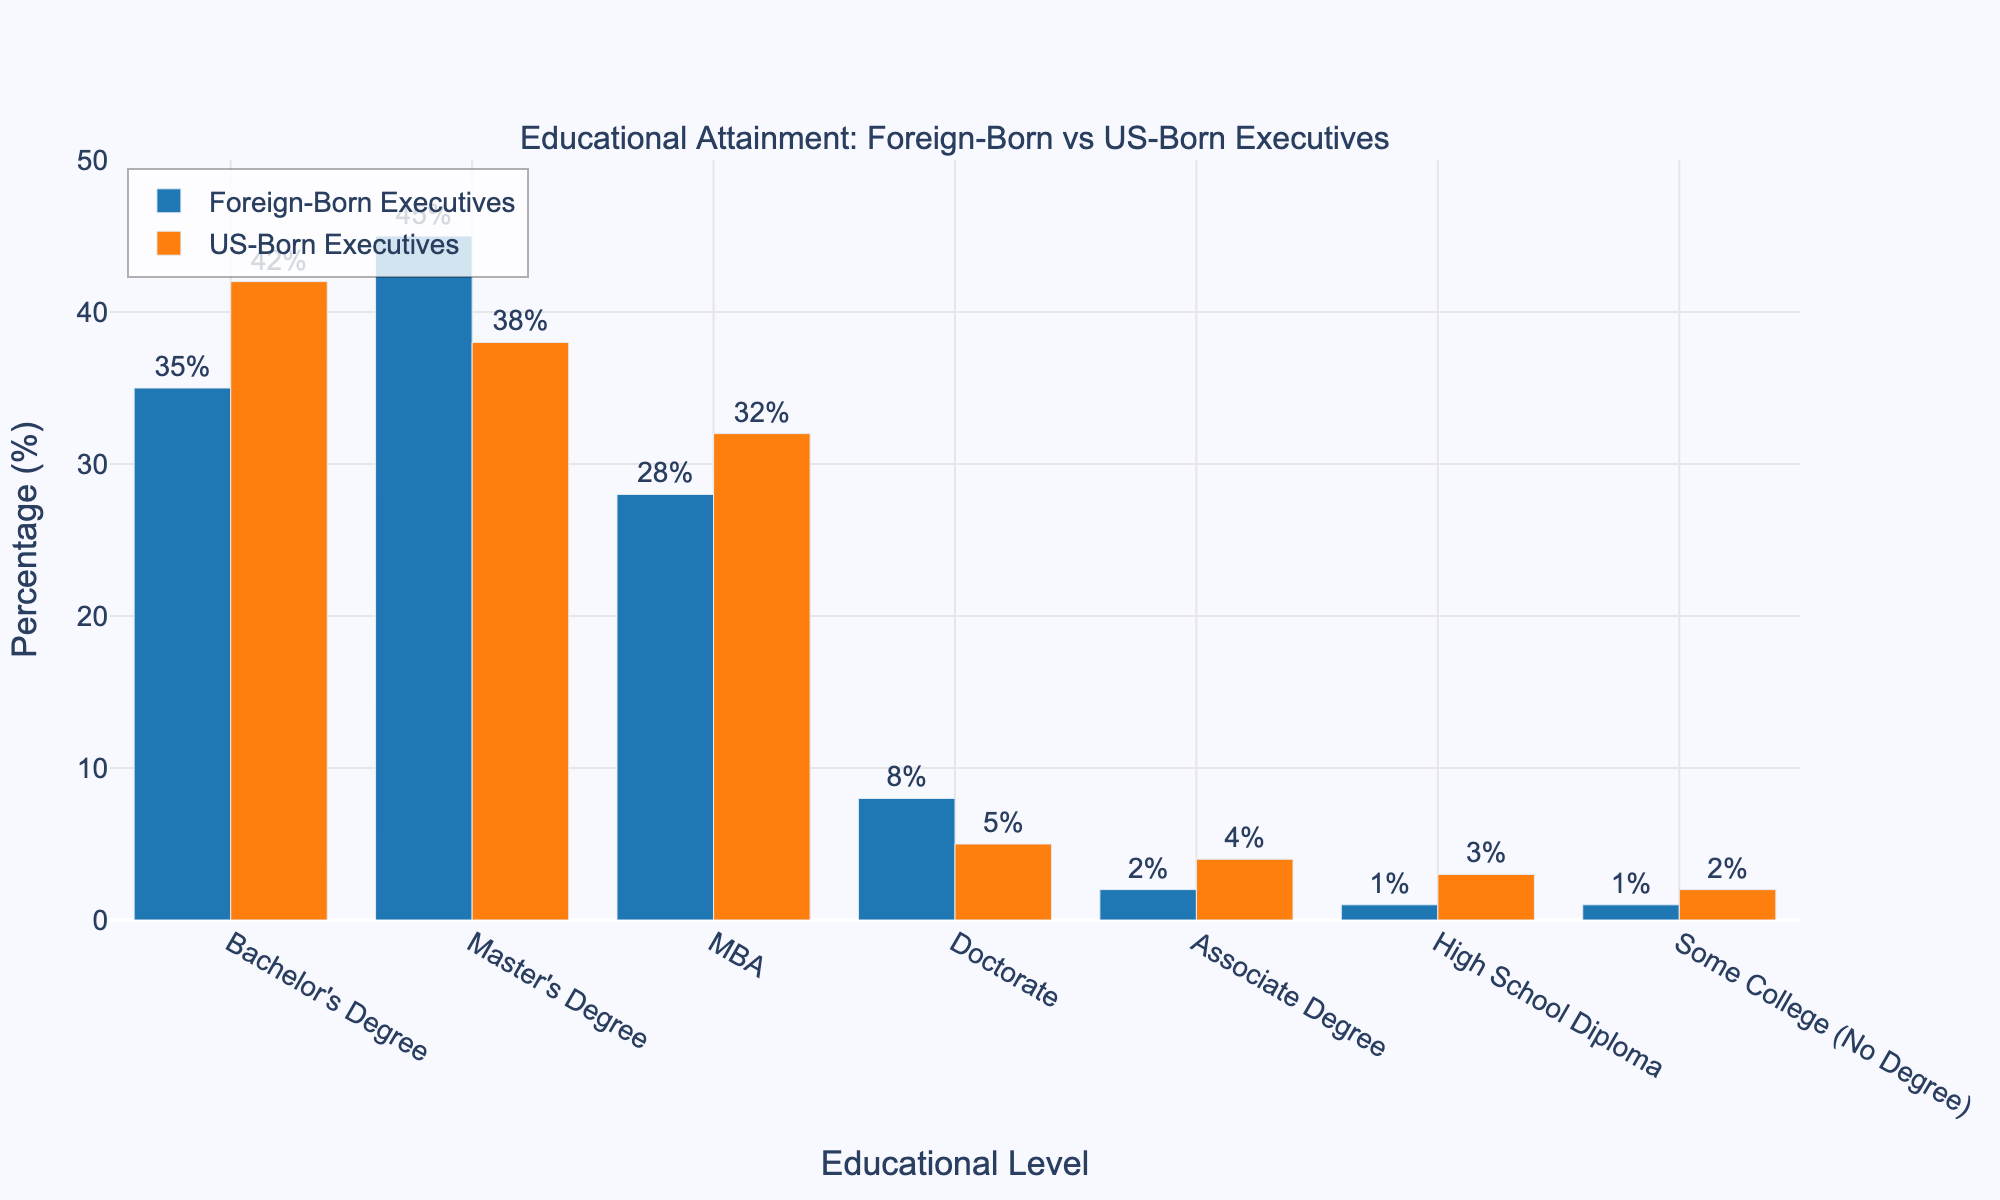What's the difference in the percentage of executives with a Bachelor's Degree between foreign-born and US-born? To find the difference, subtract the percentage of US-born executives with a Bachelor's Degree from the percentage of foreign-born executives with a Bachelor's Degree: 35% - 42% = -7%.
Answer: -7% Which group has a higher percentage of executives with a Doctorate? Comparing the two percentages, foreign-born executives have 8% with a Doctorate, while US-born executives have 5%. Since 8% is greater than 5%, foreign-born executives have a higher percentage with a Doctorate.
Answer: Foreign-born executives What is the combined percentage of foreign-born and US-born executives with an MBA? Adding the percentage of foreign-born executives with an MBA (28%) and US-born executives with an MBA (32%): 28% + 32% = 60%.
Answer: 60% What is the average percentage of executives with a Master's Degree for both groups combined? Calculate the average of the percentages of foreign-born (45%) and US-born (38%) executives with a Master's Degree: (45 + 38) / 2 = 41.5%.
Answer: 41.5% Which educational level has the largest difference in percentage between foreign-born and US-born executives? To determine the largest difference, look at the absolute differences for each educational level: Bachelor's Degree (7%), Master's Degree (7%), MBA (4%), Doctorate (3%), Associate Degree (2%), High School Diploma (2%), Some College (1%). The Bachelor's Degree and Master's Degree both have the largest differences at 7%.
Answer: Bachelor's Degree and Master's Degree What percentage of foreign-born executives have at least a Master's Degree? Sum the percentages of foreign-born executives with a Master's Degree, MBA, and Doctorate: 45% + 28% + 8% = 81%.
Answer: 81% Which group has a higher percentage of executives with less than a Bachelor's Degree (Associate Degree and below)? Sum the percentages of foreign-born executives with less than a Bachelor's Degree (1% + 1% + 2% = 4%) and US-born executives with less than a Bachelor's Degree (3% + 2% + 4% = 9%). Since 4% is less than 9%, US-born executives have a higher percentage with less than a Bachelor's Degree.
Answer: US-born executives What's the ratio of foreign-born to US-born executives with an Associate Degree? The percentage of foreign-born executives with an Associate Degree is 2%, and the percentage of US-born executives with an Associate Degree is 4%. The ratio is 2:4, which simplifies to 1:2.
Answer: 1:2 